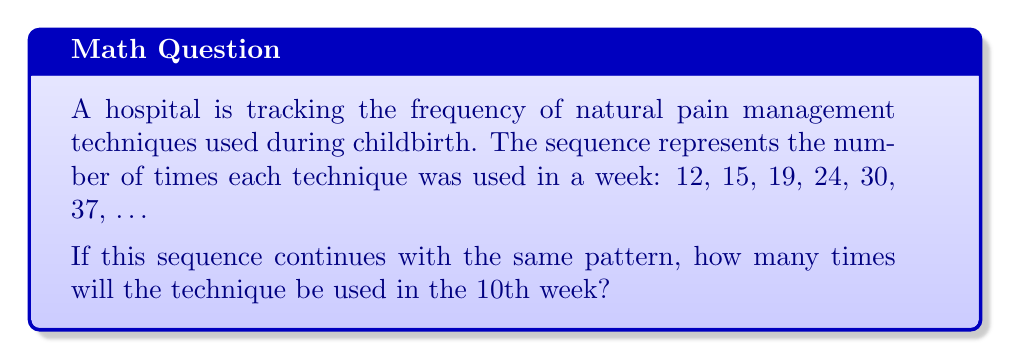Provide a solution to this math problem. To solve this problem, we need to identify the pattern in the given sequence:

1. Calculate the differences between consecutive terms:
   15 - 12 = 3
   19 - 15 = 4
   24 - 19 = 5
   30 - 24 = 6
   37 - 30 = 7

2. Observe that the differences form an arithmetic sequence: 3, 4, 5, 6, 7, ...

3. The difference between these differences is constant: 1

4. This indicates that the original sequence is a quadratic sequence.

5. The general form of a quadratic sequence is:
   $$a_n = an^2 + bn + c$$
   where $n$ is the term number, and $a$, $b$, and $c$ are constants.

6. To find $a$, $b$, and $c$, we can use the first three terms:
   $$12 = a(1)^2 + b(1) + c$$
   $$15 = a(2)^2 + b(2) + c$$
   $$19 = a(3)^2 + b(3) + c$$

7. Solving this system of equations:
   $$a = \frac{1}{2}, b = \frac{5}{2}, c = 9$$

8. Therefore, the general term of the sequence is:
   $$a_n = \frac{1}{2}n^2 + \frac{5}{2}n + 9$$

9. To find the 10th term, substitute $n = 10$:
   $$a_{10} = \frac{1}{2}(10)^2 + \frac{5}{2}(10) + 9$$
   $$a_{10} = 50 + 25 + 9 = 84$$
Answer: 84 